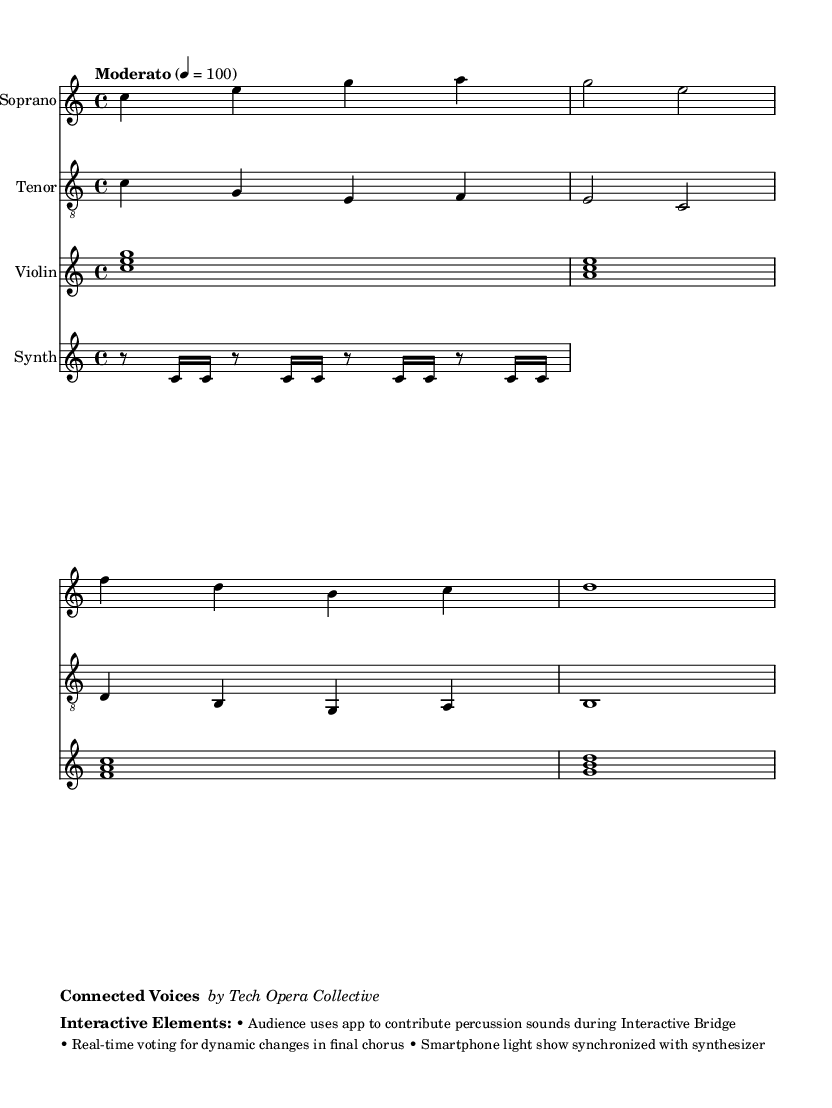What is the key signature of this music? The key signature is C major because there are no sharps or flats indicated in the score.
Answer: C major What is the time signature of the piece? The time signature is found at the beginning of the score, marked as 4/4, which means there are four beats in each measure and the quarter note gets one beat.
Answer: 4/4 What is the tempo marking for this music? The tempo marking is indicated above the score, which states "Moderato" at a speed of 100 beats per minute, suggesting a moderate pace for the performance.
Answer: Moderato 4 = 100 How many measures are in the soprano part? The soprano part consists of four measures; a simple count of the bars within the part reveals this total.
Answer: Four What type of interactive elements are incorporated in the opera? The score mentions specific interactive elements that are intended for audience participation, such as contributing percussion sounds and a real-time voting system.
Answer: Audience app contributions What vocal types are used in this opera? The opera features soprano and tenor parts, both of which are clearly labeled in the score, indicating the range of voices included in the performance.
Answer: Soprano and tenor What is the title of the opera? The title is indicated at the bottom of the markup, where it is listed as "Connected Voices" by the Tech Opera Collective, giving recognition to the work and its creators.
Answer: Connected Voices 